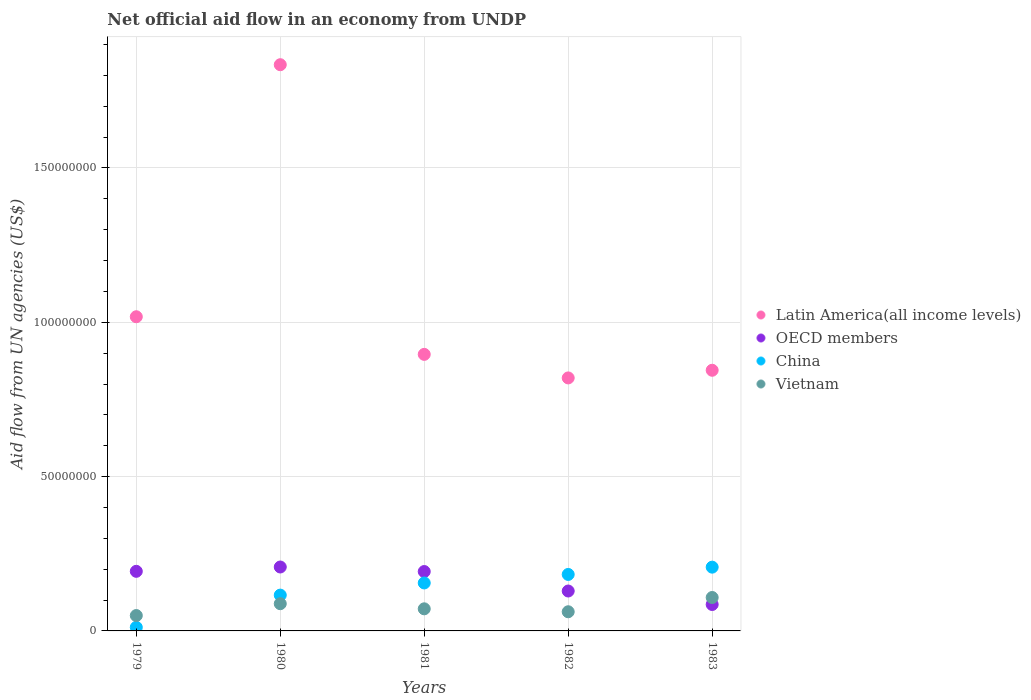What is the net official aid flow in Vietnam in 1983?
Ensure brevity in your answer.  1.08e+07. Across all years, what is the maximum net official aid flow in OECD members?
Ensure brevity in your answer.  2.07e+07. Across all years, what is the minimum net official aid flow in OECD members?
Provide a succinct answer. 8.56e+06. In which year was the net official aid flow in China minimum?
Your response must be concise. 1979. What is the total net official aid flow in China in the graph?
Provide a succinct answer. 6.73e+07. What is the difference between the net official aid flow in China in 1980 and that in 1983?
Make the answer very short. -9.06e+06. What is the difference between the net official aid flow in OECD members in 1980 and the net official aid flow in China in 1982?
Offer a terse response. 2.41e+06. What is the average net official aid flow in China per year?
Offer a very short reply. 1.35e+07. In the year 1983, what is the difference between the net official aid flow in OECD members and net official aid flow in Vietnam?
Offer a terse response. -2.27e+06. In how many years, is the net official aid flow in China greater than 70000000 US$?
Give a very brief answer. 0. What is the ratio of the net official aid flow in Vietnam in 1979 to that in 1983?
Give a very brief answer. 0.46. Is the net official aid flow in Latin America(all income levels) in 1979 less than that in 1982?
Your response must be concise. No. What is the difference between the highest and the second highest net official aid flow in Vietnam?
Offer a very short reply. 2.01e+06. What is the difference between the highest and the lowest net official aid flow in China?
Offer a terse response. 1.95e+07. In how many years, is the net official aid flow in China greater than the average net official aid flow in China taken over all years?
Offer a very short reply. 3. Is the sum of the net official aid flow in Latin America(all income levels) in 1979 and 1983 greater than the maximum net official aid flow in China across all years?
Offer a very short reply. Yes. Is it the case that in every year, the sum of the net official aid flow in China and net official aid flow in Latin America(all income levels)  is greater than the sum of net official aid flow in OECD members and net official aid flow in Vietnam?
Keep it short and to the point. Yes. Is it the case that in every year, the sum of the net official aid flow in OECD members and net official aid flow in Vietnam  is greater than the net official aid flow in China?
Ensure brevity in your answer.  No. Is the net official aid flow in OECD members strictly less than the net official aid flow in China over the years?
Ensure brevity in your answer.  No. Does the graph contain grids?
Make the answer very short. Yes. How many legend labels are there?
Give a very brief answer. 4. What is the title of the graph?
Provide a short and direct response. Net official aid flow in an economy from UNDP. What is the label or title of the X-axis?
Provide a succinct answer. Years. What is the label or title of the Y-axis?
Your answer should be compact. Aid flow from UN agencies (US$). What is the Aid flow from UN agencies (US$) in Latin America(all income levels) in 1979?
Ensure brevity in your answer.  1.02e+08. What is the Aid flow from UN agencies (US$) of OECD members in 1979?
Ensure brevity in your answer.  1.93e+07. What is the Aid flow from UN agencies (US$) in China in 1979?
Your answer should be compact. 1.16e+06. What is the Aid flow from UN agencies (US$) in Vietnam in 1979?
Make the answer very short. 4.98e+06. What is the Aid flow from UN agencies (US$) of Latin America(all income levels) in 1980?
Your response must be concise. 1.83e+08. What is the Aid flow from UN agencies (US$) in OECD members in 1980?
Provide a succinct answer. 2.07e+07. What is the Aid flow from UN agencies (US$) of China in 1980?
Make the answer very short. 1.16e+07. What is the Aid flow from UN agencies (US$) in Vietnam in 1980?
Ensure brevity in your answer.  8.82e+06. What is the Aid flow from UN agencies (US$) in Latin America(all income levels) in 1981?
Ensure brevity in your answer.  8.96e+07. What is the Aid flow from UN agencies (US$) in OECD members in 1981?
Your answer should be compact. 1.92e+07. What is the Aid flow from UN agencies (US$) in China in 1981?
Offer a very short reply. 1.55e+07. What is the Aid flow from UN agencies (US$) of Vietnam in 1981?
Give a very brief answer. 7.16e+06. What is the Aid flow from UN agencies (US$) of Latin America(all income levels) in 1982?
Make the answer very short. 8.20e+07. What is the Aid flow from UN agencies (US$) in OECD members in 1982?
Provide a short and direct response. 1.29e+07. What is the Aid flow from UN agencies (US$) of China in 1982?
Make the answer very short. 1.83e+07. What is the Aid flow from UN agencies (US$) in Vietnam in 1982?
Ensure brevity in your answer.  6.21e+06. What is the Aid flow from UN agencies (US$) of Latin America(all income levels) in 1983?
Your answer should be very brief. 8.44e+07. What is the Aid flow from UN agencies (US$) of OECD members in 1983?
Ensure brevity in your answer.  8.56e+06. What is the Aid flow from UN agencies (US$) in China in 1983?
Your answer should be very brief. 2.07e+07. What is the Aid flow from UN agencies (US$) in Vietnam in 1983?
Keep it short and to the point. 1.08e+07. Across all years, what is the maximum Aid flow from UN agencies (US$) in Latin America(all income levels)?
Give a very brief answer. 1.83e+08. Across all years, what is the maximum Aid flow from UN agencies (US$) in OECD members?
Your answer should be compact. 2.07e+07. Across all years, what is the maximum Aid flow from UN agencies (US$) in China?
Provide a short and direct response. 2.07e+07. Across all years, what is the maximum Aid flow from UN agencies (US$) of Vietnam?
Provide a succinct answer. 1.08e+07. Across all years, what is the minimum Aid flow from UN agencies (US$) in Latin America(all income levels)?
Give a very brief answer. 8.20e+07. Across all years, what is the minimum Aid flow from UN agencies (US$) of OECD members?
Your answer should be very brief. 8.56e+06. Across all years, what is the minimum Aid flow from UN agencies (US$) of China?
Ensure brevity in your answer.  1.16e+06. Across all years, what is the minimum Aid flow from UN agencies (US$) of Vietnam?
Your answer should be very brief. 4.98e+06. What is the total Aid flow from UN agencies (US$) in Latin America(all income levels) in the graph?
Keep it short and to the point. 5.41e+08. What is the total Aid flow from UN agencies (US$) in OECD members in the graph?
Provide a short and direct response. 8.08e+07. What is the total Aid flow from UN agencies (US$) of China in the graph?
Offer a terse response. 6.73e+07. What is the total Aid flow from UN agencies (US$) in Vietnam in the graph?
Give a very brief answer. 3.80e+07. What is the difference between the Aid flow from UN agencies (US$) in Latin America(all income levels) in 1979 and that in 1980?
Ensure brevity in your answer.  -8.17e+07. What is the difference between the Aid flow from UN agencies (US$) in OECD members in 1979 and that in 1980?
Provide a succinct answer. -1.40e+06. What is the difference between the Aid flow from UN agencies (US$) of China in 1979 and that in 1980?
Keep it short and to the point. -1.04e+07. What is the difference between the Aid flow from UN agencies (US$) in Vietnam in 1979 and that in 1980?
Your answer should be compact. -3.84e+06. What is the difference between the Aid flow from UN agencies (US$) in Latin America(all income levels) in 1979 and that in 1981?
Offer a very short reply. 1.22e+07. What is the difference between the Aid flow from UN agencies (US$) in China in 1979 and that in 1981?
Offer a terse response. -1.44e+07. What is the difference between the Aid flow from UN agencies (US$) in Vietnam in 1979 and that in 1981?
Make the answer very short. -2.18e+06. What is the difference between the Aid flow from UN agencies (US$) of Latin America(all income levels) in 1979 and that in 1982?
Make the answer very short. 1.98e+07. What is the difference between the Aid flow from UN agencies (US$) of OECD members in 1979 and that in 1982?
Make the answer very short. 6.38e+06. What is the difference between the Aid flow from UN agencies (US$) of China in 1979 and that in 1982?
Give a very brief answer. -1.71e+07. What is the difference between the Aid flow from UN agencies (US$) of Vietnam in 1979 and that in 1982?
Make the answer very short. -1.23e+06. What is the difference between the Aid flow from UN agencies (US$) in Latin America(all income levels) in 1979 and that in 1983?
Provide a short and direct response. 1.73e+07. What is the difference between the Aid flow from UN agencies (US$) in OECD members in 1979 and that in 1983?
Offer a very short reply. 1.08e+07. What is the difference between the Aid flow from UN agencies (US$) in China in 1979 and that in 1983?
Keep it short and to the point. -1.95e+07. What is the difference between the Aid flow from UN agencies (US$) in Vietnam in 1979 and that in 1983?
Your response must be concise. -5.85e+06. What is the difference between the Aid flow from UN agencies (US$) of Latin America(all income levels) in 1980 and that in 1981?
Give a very brief answer. 9.38e+07. What is the difference between the Aid flow from UN agencies (US$) of OECD members in 1980 and that in 1981?
Your answer should be compact. 1.47e+06. What is the difference between the Aid flow from UN agencies (US$) in China in 1980 and that in 1981?
Provide a short and direct response. -3.94e+06. What is the difference between the Aid flow from UN agencies (US$) of Vietnam in 1980 and that in 1981?
Provide a short and direct response. 1.66e+06. What is the difference between the Aid flow from UN agencies (US$) of Latin America(all income levels) in 1980 and that in 1982?
Offer a terse response. 1.01e+08. What is the difference between the Aid flow from UN agencies (US$) in OECD members in 1980 and that in 1982?
Your response must be concise. 7.78e+06. What is the difference between the Aid flow from UN agencies (US$) of China in 1980 and that in 1982?
Provide a succinct answer. -6.70e+06. What is the difference between the Aid flow from UN agencies (US$) in Vietnam in 1980 and that in 1982?
Give a very brief answer. 2.61e+06. What is the difference between the Aid flow from UN agencies (US$) in Latin America(all income levels) in 1980 and that in 1983?
Give a very brief answer. 9.90e+07. What is the difference between the Aid flow from UN agencies (US$) of OECD members in 1980 and that in 1983?
Keep it short and to the point. 1.22e+07. What is the difference between the Aid flow from UN agencies (US$) of China in 1980 and that in 1983?
Give a very brief answer. -9.06e+06. What is the difference between the Aid flow from UN agencies (US$) of Vietnam in 1980 and that in 1983?
Your response must be concise. -2.01e+06. What is the difference between the Aid flow from UN agencies (US$) of Latin America(all income levels) in 1981 and that in 1982?
Provide a succinct answer. 7.63e+06. What is the difference between the Aid flow from UN agencies (US$) of OECD members in 1981 and that in 1982?
Your response must be concise. 6.31e+06. What is the difference between the Aid flow from UN agencies (US$) in China in 1981 and that in 1982?
Your response must be concise. -2.76e+06. What is the difference between the Aid flow from UN agencies (US$) in Vietnam in 1981 and that in 1982?
Your answer should be very brief. 9.50e+05. What is the difference between the Aid flow from UN agencies (US$) in Latin America(all income levels) in 1981 and that in 1983?
Your answer should be compact. 5.15e+06. What is the difference between the Aid flow from UN agencies (US$) in OECD members in 1981 and that in 1983?
Your answer should be very brief. 1.07e+07. What is the difference between the Aid flow from UN agencies (US$) of China in 1981 and that in 1983?
Give a very brief answer. -5.12e+06. What is the difference between the Aid flow from UN agencies (US$) of Vietnam in 1981 and that in 1983?
Your answer should be very brief. -3.67e+06. What is the difference between the Aid flow from UN agencies (US$) of Latin America(all income levels) in 1982 and that in 1983?
Ensure brevity in your answer.  -2.48e+06. What is the difference between the Aid flow from UN agencies (US$) of OECD members in 1982 and that in 1983?
Your answer should be compact. 4.37e+06. What is the difference between the Aid flow from UN agencies (US$) of China in 1982 and that in 1983?
Offer a terse response. -2.36e+06. What is the difference between the Aid flow from UN agencies (US$) of Vietnam in 1982 and that in 1983?
Offer a very short reply. -4.62e+06. What is the difference between the Aid flow from UN agencies (US$) of Latin America(all income levels) in 1979 and the Aid flow from UN agencies (US$) of OECD members in 1980?
Give a very brief answer. 8.11e+07. What is the difference between the Aid flow from UN agencies (US$) of Latin America(all income levels) in 1979 and the Aid flow from UN agencies (US$) of China in 1980?
Offer a terse response. 9.02e+07. What is the difference between the Aid flow from UN agencies (US$) of Latin America(all income levels) in 1979 and the Aid flow from UN agencies (US$) of Vietnam in 1980?
Offer a terse response. 9.30e+07. What is the difference between the Aid flow from UN agencies (US$) in OECD members in 1979 and the Aid flow from UN agencies (US$) in China in 1980?
Offer a terse response. 7.71e+06. What is the difference between the Aid flow from UN agencies (US$) of OECD members in 1979 and the Aid flow from UN agencies (US$) of Vietnam in 1980?
Ensure brevity in your answer.  1.05e+07. What is the difference between the Aid flow from UN agencies (US$) of China in 1979 and the Aid flow from UN agencies (US$) of Vietnam in 1980?
Offer a terse response. -7.66e+06. What is the difference between the Aid flow from UN agencies (US$) of Latin America(all income levels) in 1979 and the Aid flow from UN agencies (US$) of OECD members in 1981?
Your answer should be very brief. 8.26e+07. What is the difference between the Aid flow from UN agencies (US$) of Latin America(all income levels) in 1979 and the Aid flow from UN agencies (US$) of China in 1981?
Ensure brevity in your answer.  8.62e+07. What is the difference between the Aid flow from UN agencies (US$) of Latin America(all income levels) in 1979 and the Aid flow from UN agencies (US$) of Vietnam in 1981?
Provide a short and direct response. 9.46e+07. What is the difference between the Aid flow from UN agencies (US$) of OECD members in 1979 and the Aid flow from UN agencies (US$) of China in 1981?
Your answer should be compact. 3.77e+06. What is the difference between the Aid flow from UN agencies (US$) of OECD members in 1979 and the Aid flow from UN agencies (US$) of Vietnam in 1981?
Give a very brief answer. 1.22e+07. What is the difference between the Aid flow from UN agencies (US$) in China in 1979 and the Aid flow from UN agencies (US$) in Vietnam in 1981?
Make the answer very short. -6.00e+06. What is the difference between the Aid flow from UN agencies (US$) in Latin America(all income levels) in 1979 and the Aid flow from UN agencies (US$) in OECD members in 1982?
Your answer should be very brief. 8.89e+07. What is the difference between the Aid flow from UN agencies (US$) in Latin America(all income levels) in 1979 and the Aid flow from UN agencies (US$) in China in 1982?
Make the answer very short. 8.35e+07. What is the difference between the Aid flow from UN agencies (US$) in Latin America(all income levels) in 1979 and the Aid flow from UN agencies (US$) in Vietnam in 1982?
Your answer should be very brief. 9.56e+07. What is the difference between the Aid flow from UN agencies (US$) of OECD members in 1979 and the Aid flow from UN agencies (US$) of China in 1982?
Provide a succinct answer. 1.01e+06. What is the difference between the Aid flow from UN agencies (US$) of OECD members in 1979 and the Aid flow from UN agencies (US$) of Vietnam in 1982?
Make the answer very short. 1.31e+07. What is the difference between the Aid flow from UN agencies (US$) in China in 1979 and the Aid flow from UN agencies (US$) in Vietnam in 1982?
Your answer should be compact. -5.05e+06. What is the difference between the Aid flow from UN agencies (US$) of Latin America(all income levels) in 1979 and the Aid flow from UN agencies (US$) of OECD members in 1983?
Provide a short and direct response. 9.32e+07. What is the difference between the Aid flow from UN agencies (US$) in Latin America(all income levels) in 1979 and the Aid flow from UN agencies (US$) in China in 1983?
Offer a terse response. 8.11e+07. What is the difference between the Aid flow from UN agencies (US$) of Latin America(all income levels) in 1979 and the Aid flow from UN agencies (US$) of Vietnam in 1983?
Give a very brief answer. 9.10e+07. What is the difference between the Aid flow from UN agencies (US$) of OECD members in 1979 and the Aid flow from UN agencies (US$) of China in 1983?
Offer a terse response. -1.35e+06. What is the difference between the Aid flow from UN agencies (US$) of OECD members in 1979 and the Aid flow from UN agencies (US$) of Vietnam in 1983?
Give a very brief answer. 8.48e+06. What is the difference between the Aid flow from UN agencies (US$) of China in 1979 and the Aid flow from UN agencies (US$) of Vietnam in 1983?
Keep it short and to the point. -9.67e+06. What is the difference between the Aid flow from UN agencies (US$) of Latin America(all income levels) in 1980 and the Aid flow from UN agencies (US$) of OECD members in 1981?
Your response must be concise. 1.64e+08. What is the difference between the Aid flow from UN agencies (US$) of Latin America(all income levels) in 1980 and the Aid flow from UN agencies (US$) of China in 1981?
Offer a terse response. 1.68e+08. What is the difference between the Aid flow from UN agencies (US$) of Latin America(all income levels) in 1980 and the Aid flow from UN agencies (US$) of Vietnam in 1981?
Your response must be concise. 1.76e+08. What is the difference between the Aid flow from UN agencies (US$) of OECD members in 1980 and the Aid flow from UN agencies (US$) of China in 1981?
Offer a very short reply. 5.17e+06. What is the difference between the Aid flow from UN agencies (US$) of OECD members in 1980 and the Aid flow from UN agencies (US$) of Vietnam in 1981?
Make the answer very short. 1.36e+07. What is the difference between the Aid flow from UN agencies (US$) of China in 1980 and the Aid flow from UN agencies (US$) of Vietnam in 1981?
Your answer should be compact. 4.44e+06. What is the difference between the Aid flow from UN agencies (US$) of Latin America(all income levels) in 1980 and the Aid flow from UN agencies (US$) of OECD members in 1982?
Ensure brevity in your answer.  1.71e+08. What is the difference between the Aid flow from UN agencies (US$) in Latin America(all income levels) in 1980 and the Aid flow from UN agencies (US$) in China in 1982?
Provide a succinct answer. 1.65e+08. What is the difference between the Aid flow from UN agencies (US$) in Latin America(all income levels) in 1980 and the Aid flow from UN agencies (US$) in Vietnam in 1982?
Provide a short and direct response. 1.77e+08. What is the difference between the Aid flow from UN agencies (US$) of OECD members in 1980 and the Aid flow from UN agencies (US$) of China in 1982?
Give a very brief answer. 2.41e+06. What is the difference between the Aid flow from UN agencies (US$) in OECD members in 1980 and the Aid flow from UN agencies (US$) in Vietnam in 1982?
Give a very brief answer. 1.45e+07. What is the difference between the Aid flow from UN agencies (US$) in China in 1980 and the Aid flow from UN agencies (US$) in Vietnam in 1982?
Your answer should be compact. 5.39e+06. What is the difference between the Aid flow from UN agencies (US$) in Latin America(all income levels) in 1980 and the Aid flow from UN agencies (US$) in OECD members in 1983?
Your response must be concise. 1.75e+08. What is the difference between the Aid flow from UN agencies (US$) in Latin America(all income levels) in 1980 and the Aid flow from UN agencies (US$) in China in 1983?
Give a very brief answer. 1.63e+08. What is the difference between the Aid flow from UN agencies (US$) in Latin America(all income levels) in 1980 and the Aid flow from UN agencies (US$) in Vietnam in 1983?
Your answer should be compact. 1.73e+08. What is the difference between the Aid flow from UN agencies (US$) in OECD members in 1980 and the Aid flow from UN agencies (US$) in Vietnam in 1983?
Your answer should be compact. 9.88e+06. What is the difference between the Aid flow from UN agencies (US$) of China in 1980 and the Aid flow from UN agencies (US$) of Vietnam in 1983?
Your answer should be compact. 7.70e+05. What is the difference between the Aid flow from UN agencies (US$) of Latin America(all income levels) in 1981 and the Aid flow from UN agencies (US$) of OECD members in 1982?
Ensure brevity in your answer.  7.67e+07. What is the difference between the Aid flow from UN agencies (US$) of Latin America(all income levels) in 1981 and the Aid flow from UN agencies (US$) of China in 1982?
Offer a terse response. 7.13e+07. What is the difference between the Aid flow from UN agencies (US$) in Latin America(all income levels) in 1981 and the Aid flow from UN agencies (US$) in Vietnam in 1982?
Provide a short and direct response. 8.34e+07. What is the difference between the Aid flow from UN agencies (US$) in OECD members in 1981 and the Aid flow from UN agencies (US$) in China in 1982?
Your response must be concise. 9.40e+05. What is the difference between the Aid flow from UN agencies (US$) in OECD members in 1981 and the Aid flow from UN agencies (US$) in Vietnam in 1982?
Offer a terse response. 1.30e+07. What is the difference between the Aid flow from UN agencies (US$) in China in 1981 and the Aid flow from UN agencies (US$) in Vietnam in 1982?
Your response must be concise. 9.33e+06. What is the difference between the Aid flow from UN agencies (US$) in Latin America(all income levels) in 1981 and the Aid flow from UN agencies (US$) in OECD members in 1983?
Give a very brief answer. 8.10e+07. What is the difference between the Aid flow from UN agencies (US$) in Latin America(all income levels) in 1981 and the Aid flow from UN agencies (US$) in China in 1983?
Your response must be concise. 6.89e+07. What is the difference between the Aid flow from UN agencies (US$) of Latin America(all income levels) in 1981 and the Aid flow from UN agencies (US$) of Vietnam in 1983?
Your answer should be very brief. 7.88e+07. What is the difference between the Aid flow from UN agencies (US$) of OECD members in 1981 and the Aid flow from UN agencies (US$) of China in 1983?
Provide a short and direct response. -1.42e+06. What is the difference between the Aid flow from UN agencies (US$) in OECD members in 1981 and the Aid flow from UN agencies (US$) in Vietnam in 1983?
Keep it short and to the point. 8.41e+06. What is the difference between the Aid flow from UN agencies (US$) in China in 1981 and the Aid flow from UN agencies (US$) in Vietnam in 1983?
Provide a succinct answer. 4.71e+06. What is the difference between the Aid flow from UN agencies (US$) of Latin America(all income levels) in 1982 and the Aid flow from UN agencies (US$) of OECD members in 1983?
Make the answer very short. 7.34e+07. What is the difference between the Aid flow from UN agencies (US$) of Latin America(all income levels) in 1982 and the Aid flow from UN agencies (US$) of China in 1983?
Your answer should be very brief. 6.13e+07. What is the difference between the Aid flow from UN agencies (US$) of Latin America(all income levels) in 1982 and the Aid flow from UN agencies (US$) of Vietnam in 1983?
Provide a short and direct response. 7.11e+07. What is the difference between the Aid flow from UN agencies (US$) in OECD members in 1982 and the Aid flow from UN agencies (US$) in China in 1983?
Your answer should be compact. -7.73e+06. What is the difference between the Aid flow from UN agencies (US$) in OECD members in 1982 and the Aid flow from UN agencies (US$) in Vietnam in 1983?
Offer a terse response. 2.10e+06. What is the difference between the Aid flow from UN agencies (US$) of China in 1982 and the Aid flow from UN agencies (US$) of Vietnam in 1983?
Provide a succinct answer. 7.47e+06. What is the average Aid flow from UN agencies (US$) of Latin America(all income levels) per year?
Provide a succinct answer. 1.08e+08. What is the average Aid flow from UN agencies (US$) in OECD members per year?
Keep it short and to the point. 1.62e+07. What is the average Aid flow from UN agencies (US$) in China per year?
Your answer should be compact. 1.35e+07. What is the average Aid flow from UN agencies (US$) of Vietnam per year?
Provide a succinct answer. 7.60e+06. In the year 1979, what is the difference between the Aid flow from UN agencies (US$) of Latin America(all income levels) and Aid flow from UN agencies (US$) of OECD members?
Keep it short and to the point. 8.25e+07. In the year 1979, what is the difference between the Aid flow from UN agencies (US$) of Latin America(all income levels) and Aid flow from UN agencies (US$) of China?
Provide a succinct answer. 1.01e+08. In the year 1979, what is the difference between the Aid flow from UN agencies (US$) in Latin America(all income levels) and Aid flow from UN agencies (US$) in Vietnam?
Your answer should be compact. 9.68e+07. In the year 1979, what is the difference between the Aid flow from UN agencies (US$) of OECD members and Aid flow from UN agencies (US$) of China?
Provide a succinct answer. 1.82e+07. In the year 1979, what is the difference between the Aid flow from UN agencies (US$) of OECD members and Aid flow from UN agencies (US$) of Vietnam?
Make the answer very short. 1.43e+07. In the year 1979, what is the difference between the Aid flow from UN agencies (US$) of China and Aid flow from UN agencies (US$) of Vietnam?
Your answer should be compact. -3.82e+06. In the year 1980, what is the difference between the Aid flow from UN agencies (US$) of Latin America(all income levels) and Aid flow from UN agencies (US$) of OECD members?
Your answer should be very brief. 1.63e+08. In the year 1980, what is the difference between the Aid flow from UN agencies (US$) in Latin America(all income levels) and Aid flow from UN agencies (US$) in China?
Provide a short and direct response. 1.72e+08. In the year 1980, what is the difference between the Aid flow from UN agencies (US$) of Latin America(all income levels) and Aid flow from UN agencies (US$) of Vietnam?
Make the answer very short. 1.75e+08. In the year 1980, what is the difference between the Aid flow from UN agencies (US$) in OECD members and Aid flow from UN agencies (US$) in China?
Make the answer very short. 9.11e+06. In the year 1980, what is the difference between the Aid flow from UN agencies (US$) of OECD members and Aid flow from UN agencies (US$) of Vietnam?
Keep it short and to the point. 1.19e+07. In the year 1980, what is the difference between the Aid flow from UN agencies (US$) of China and Aid flow from UN agencies (US$) of Vietnam?
Offer a terse response. 2.78e+06. In the year 1981, what is the difference between the Aid flow from UN agencies (US$) of Latin America(all income levels) and Aid flow from UN agencies (US$) of OECD members?
Offer a terse response. 7.04e+07. In the year 1981, what is the difference between the Aid flow from UN agencies (US$) in Latin America(all income levels) and Aid flow from UN agencies (US$) in China?
Your answer should be compact. 7.41e+07. In the year 1981, what is the difference between the Aid flow from UN agencies (US$) of Latin America(all income levels) and Aid flow from UN agencies (US$) of Vietnam?
Provide a succinct answer. 8.24e+07. In the year 1981, what is the difference between the Aid flow from UN agencies (US$) of OECD members and Aid flow from UN agencies (US$) of China?
Make the answer very short. 3.70e+06. In the year 1981, what is the difference between the Aid flow from UN agencies (US$) of OECD members and Aid flow from UN agencies (US$) of Vietnam?
Offer a terse response. 1.21e+07. In the year 1981, what is the difference between the Aid flow from UN agencies (US$) of China and Aid flow from UN agencies (US$) of Vietnam?
Keep it short and to the point. 8.38e+06. In the year 1982, what is the difference between the Aid flow from UN agencies (US$) in Latin America(all income levels) and Aid flow from UN agencies (US$) in OECD members?
Your answer should be very brief. 6.90e+07. In the year 1982, what is the difference between the Aid flow from UN agencies (US$) in Latin America(all income levels) and Aid flow from UN agencies (US$) in China?
Make the answer very short. 6.37e+07. In the year 1982, what is the difference between the Aid flow from UN agencies (US$) of Latin America(all income levels) and Aid flow from UN agencies (US$) of Vietnam?
Offer a very short reply. 7.58e+07. In the year 1982, what is the difference between the Aid flow from UN agencies (US$) of OECD members and Aid flow from UN agencies (US$) of China?
Offer a very short reply. -5.37e+06. In the year 1982, what is the difference between the Aid flow from UN agencies (US$) of OECD members and Aid flow from UN agencies (US$) of Vietnam?
Provide a short and direct response. 6.72e+06. In the year 1982, what is the difference between the Aid flow from UN agencies (US$) in China and Aid flow from UN agencies (US$) in Vietnam?
Your answer should be very brief. 1.21e+07. In the year 1983, what is the difference between the Aid flow from UN agencies (US$) of Latin America(all income levels) and Aid flow from UN agencies (US$) of OECD members?
Provide a succinct answer. 7.59e+07. In the year 1983, what is the difference between the Aid flow from UN agencies (US$) of Latin America(all income levels) and Aid flow from UN agencies (US$) of China?
Your answer should be compact. 6.38e+07. In the year 1983, what is the difference between the Aid flow from UN agencies (US$) of Latin America(all income levels) and Aid flow from UN agencies (US$) of Vietnam?
Give a very brief answer. 7.36e+07. In the year 1983, what is the difference between the Aid flow from UN agencies (US$) in OECD members and Aid flow from UN agencies (US$) in China?
Provide a succinct answer. -1.21e+07. In the year 1983, what is the difference between the Aid flow from UN agencies (US$) in OECD members and Aid flow from UN agencies (US$) in Vietnam?
Your answer should be compact. -2.27e+06. In the year 1983, what is the difference between the Aid flow from UN agencies (US$) of China and Aid flow from UN agencies (US$) of Vietnam?
Provide a short and direct response. 9.83e+06. What is the ratio of the Aid flow from UN agencies (US$) in Latin America(all income levels) in 1979 to that in 1980?
Make the answer very short. 0.55. What is the ratio of the Aid flow from UN agencies (US$) of OECD members in 1979 to that in 1980?
Give a very brief answer. 0.93. What is the ratio of the Aid flow from UN agencies (US$) in Vietnam in 1979 to that in 1980?
Your answer should be very brief. 0.56. What is the ratio of the Aid flow from UN agencies (US$) of Latin America(all income levels) in 1979 to that in 1981?
Give a very brief answer. 1.14. What is the ratio of the Aid flow from UN agencies (US$) of China in 1979 to that in 1981?
Keep it short and to the point. 0.07. What is the ratio of the Aid flow from UN agencies (US$) of Vietnam in 1979 to that in 1981?
Provide a short and direct response. 0.7. What is the ratio of the Aid flow from UN agencies (US$) of Latin America(all income levels) in 1979 to that in 1982?
Your answer should be very brief. 1.24. What is the ratio of the Aid flow from UN agencies (US$) of OECD members in 1979 to that in 1982?
Give a very brief answer. 1.49. What is the ratio of the Aid flow from UN agencies (US$) of China in 1979 to that in 1982?
Your answer should be compact. 0.06. What is the ratio of the Aid flow from UN agencies (US$) of Vietnam in 1979 to that in 1982?
Make the answer very short. 0.8. What is the ratio of the Aid flow from UN agencies (US$) in Latin America(all income levels) in 1979 to that in 1983?
Provide a succinct answer. 1.21. What is the ratio of the Aid flow from UN agencies (US$) of OECD members in 1979 to that in 1983?
Your answer should be very brief. 2.26. What is the ratio of the Aid flow from UN agencies (US$) in China in 1979 to that in 1983?
Provide a short and direct response. 0.06. What is the ratio of the Aid flow from UN agencies (US$) of Vietnam in 1979 to that in 1983?
Offer a very short reply. 0.46. What is the ratio of the Aid flow from UN agencies (US$) of Latin America(all income levels) in 1980 to that in 1981?
Offer a terse response. 2.05. What is the ratio of the Aid flow from UN agencies (US$) of OECD members in 1980 to that in 1981?
Offer a very short reply. 1.08. What is the ratio of the Aid flow from UN agencies (US$) of China in 1980 to that in 1981?
Your response must be concise. 0.75. What is the ratio of the Aid flow from UN agencies (US$) of Vietnam in 1980 to that in 1981?
Ensure brevity in your answer.  1.23. What is the ratio of the Aid flow from UN agencies (US$) in Latin America(all income levels) in 1980 to that in 1982?
Provide a short and direct response. 2.24. What is the ratio of the Aid flow from UN agencies (US$) of OECD members in 1980 to that in 1982?
Give a very brief answer. 1.6. What is the ratio of the Aid flow from UN agencies (US$) in China in 1980 to that in 1982?
Offer a terse response. 0.63. What is the ratio of the Aid flow from UN agencies (US$) in Vietnam in 1980 to that in 1982?
Offer a terse response. 1.42. What is the ratio of the Aid flow from UN agencies (US$) of Latin America(all income levels) in 1980 to that in 1983?
Provide a succinct answer. 2.17. What is the ratio of the Aid flow from UN agencies (US$) of OECD members in 1980 to that in 1983?
Your response must be concise. 2.42. What is the ratio of the Aid flow from UN agencies (US$) in China in 1980 to that in 1983?
Provide a succinct answer. 0.56. What is the ratio of the Aid flow from UN agencies (US$) of Vietnam in 1980 to that in 1983?
Your answer should be very brief. 0.81. What is the ratio of the Aid flow from UN agencies (US$) of Latin America(all income levels) in 1981 to that in 1982?
Provide a succinct answer. 1.09. What is the ratio of the Aid flow from UN agencies (US$) in OECD members in 1981 to that in 1982?
Give a very brief answer. 1.49. What is the ratio of the Aid flow from UN agencies (US$) in China in 1981 to that in 1982?
Your response must be concise. 0.85. What is the ratio of the Aid flow from UN agencies (US$) in Vietnam in 1981 to that in 1982?
Your answer should be compact. 1.15. What is the ratio of the Aid flow from UN agencies (US$) in Latin America(all income levels) in 1981 to that in 1983?
Give a very brief answer. 1.06. What is the ratio of the Aid flow from UN agencies (US$) of OECD members in 1981 to that in 1983?
Make the answer very short. 2.25. What is the ratio of the Aid flow from UN agencies (US$) in China in 1981 to that in 1983?
Keep it short and to the point. 0.75. What is the ratio of the Aid flow from UN agencies (US$) in Vietnam in 1981 to that in 1983?
Offer a terse response. 0.66. What is the ratio of the Aid flow from UN agencies (US$) of Latin America(all income levels) in 1982 to that in 1983?
Offer a terse response. 0.97. What is the ratio of the Aid flow from UN agencies (US$) in OECD members in 1982 to that in 1983?
Keep it short and to the point. 1.51. What is the ratio of the Aid flow from UN agencies (US$) in China in 1982 to that in 1983?
Ensure brevity in your answer.  0.89. What is the ratio of the Aid flow from UN agencies (US$) of Vietnam in 1982 to that in 1983?
Provide a short and direct response. 0.57. What is the difference between the highest and the second highest Aid flow from UN agencies (US$) in Latin America(all income levels)?
Make the answer very short. 8.17e+07. What is the difference between the highest and the second highest Aid flow from UN agencies (US$) in OECD members?
Provide a short and direct response. 1.40e+06. What is the difference between the highest and the second highest Aid flow from UN agencies (US$) in China?
Your answer should be compact. 2.36e+06. What is the difference between the highest and the second highest Aid flow from UN agencies (US$) in Vietnam?
Ensure brevity in your answer.  2.01e+06. What is the difference between the highest and the lowest Aid flow from UN agencies (US$) in Latin America(all income levels)?
Provide a succinct answer. 1.01e+08. What is the difference between the highest and the lowest Aid flow from UN agencies (US$) in OECD members?
Provide a short and direct response. 1.22e+07. What is the difference between the highest and the lowest Aid flow from UN agencies (US$) in China?
Provide a short and direct response. 1.95e+07. What is the difference between the highest and the lowest Aid flow from UN agencies (US$) of Vietnam?
Your answer should be compact. 5.85e+06. 